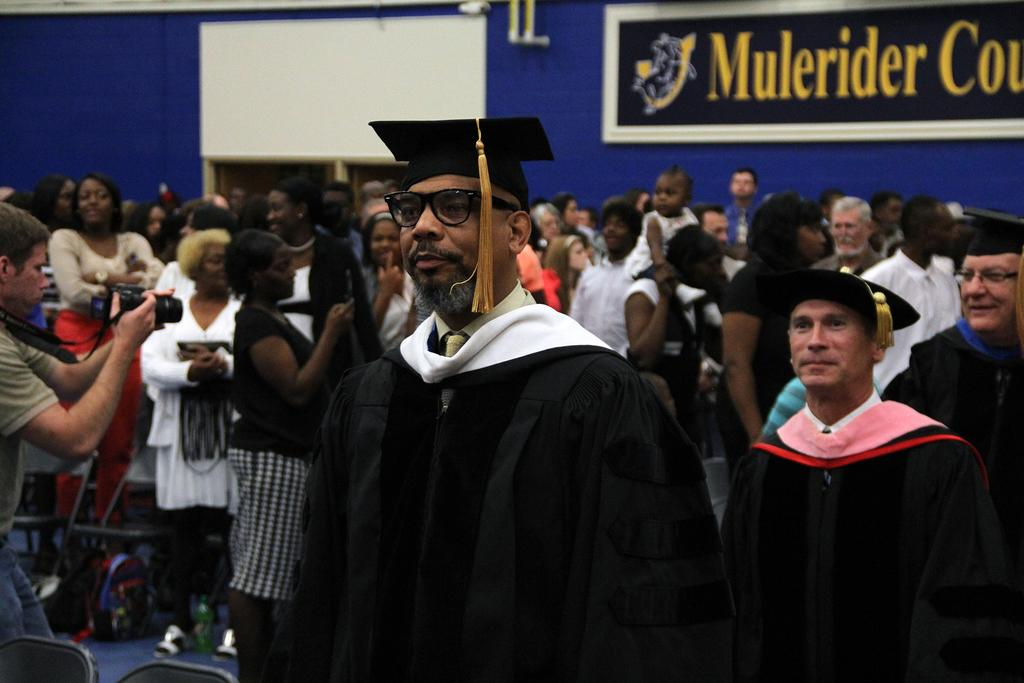How many people are present in the image? There are many people in the image. Can you describe any specific furniture in the image? Yes, there is a chair on the left bottom of the image. What color is the wall visible in the image? The wall is blue in color. What is located on the right top of the image? There is a board on the right top of the image. What type of equipment can be seen in the image? Cameras are visible in the image. Can you tell me where the bottle is located in the image? There is no bottle present in the image. What type of bird can be seen flying in the image? There are no birds visible in the image. 